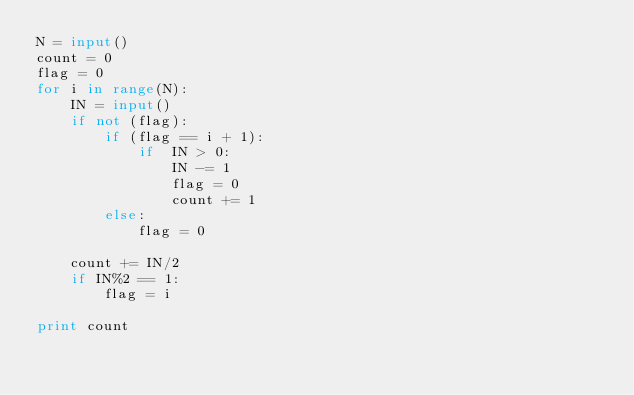Convert code to text. <code><loc_0><loc_0><loc_500><loc_500><_Python_>N = input()
count = 0
flag = 0
for i in range(N):
    IN = input()
    if not (flag):
        if (flag == i + 1):
            if  IN > 0:
                IN -= 1
                flag = 0
                count += 1
        else:
            flag = 0

    count += IN/2
    if IN%2 == 1:
        flag = i

print count
</code> 